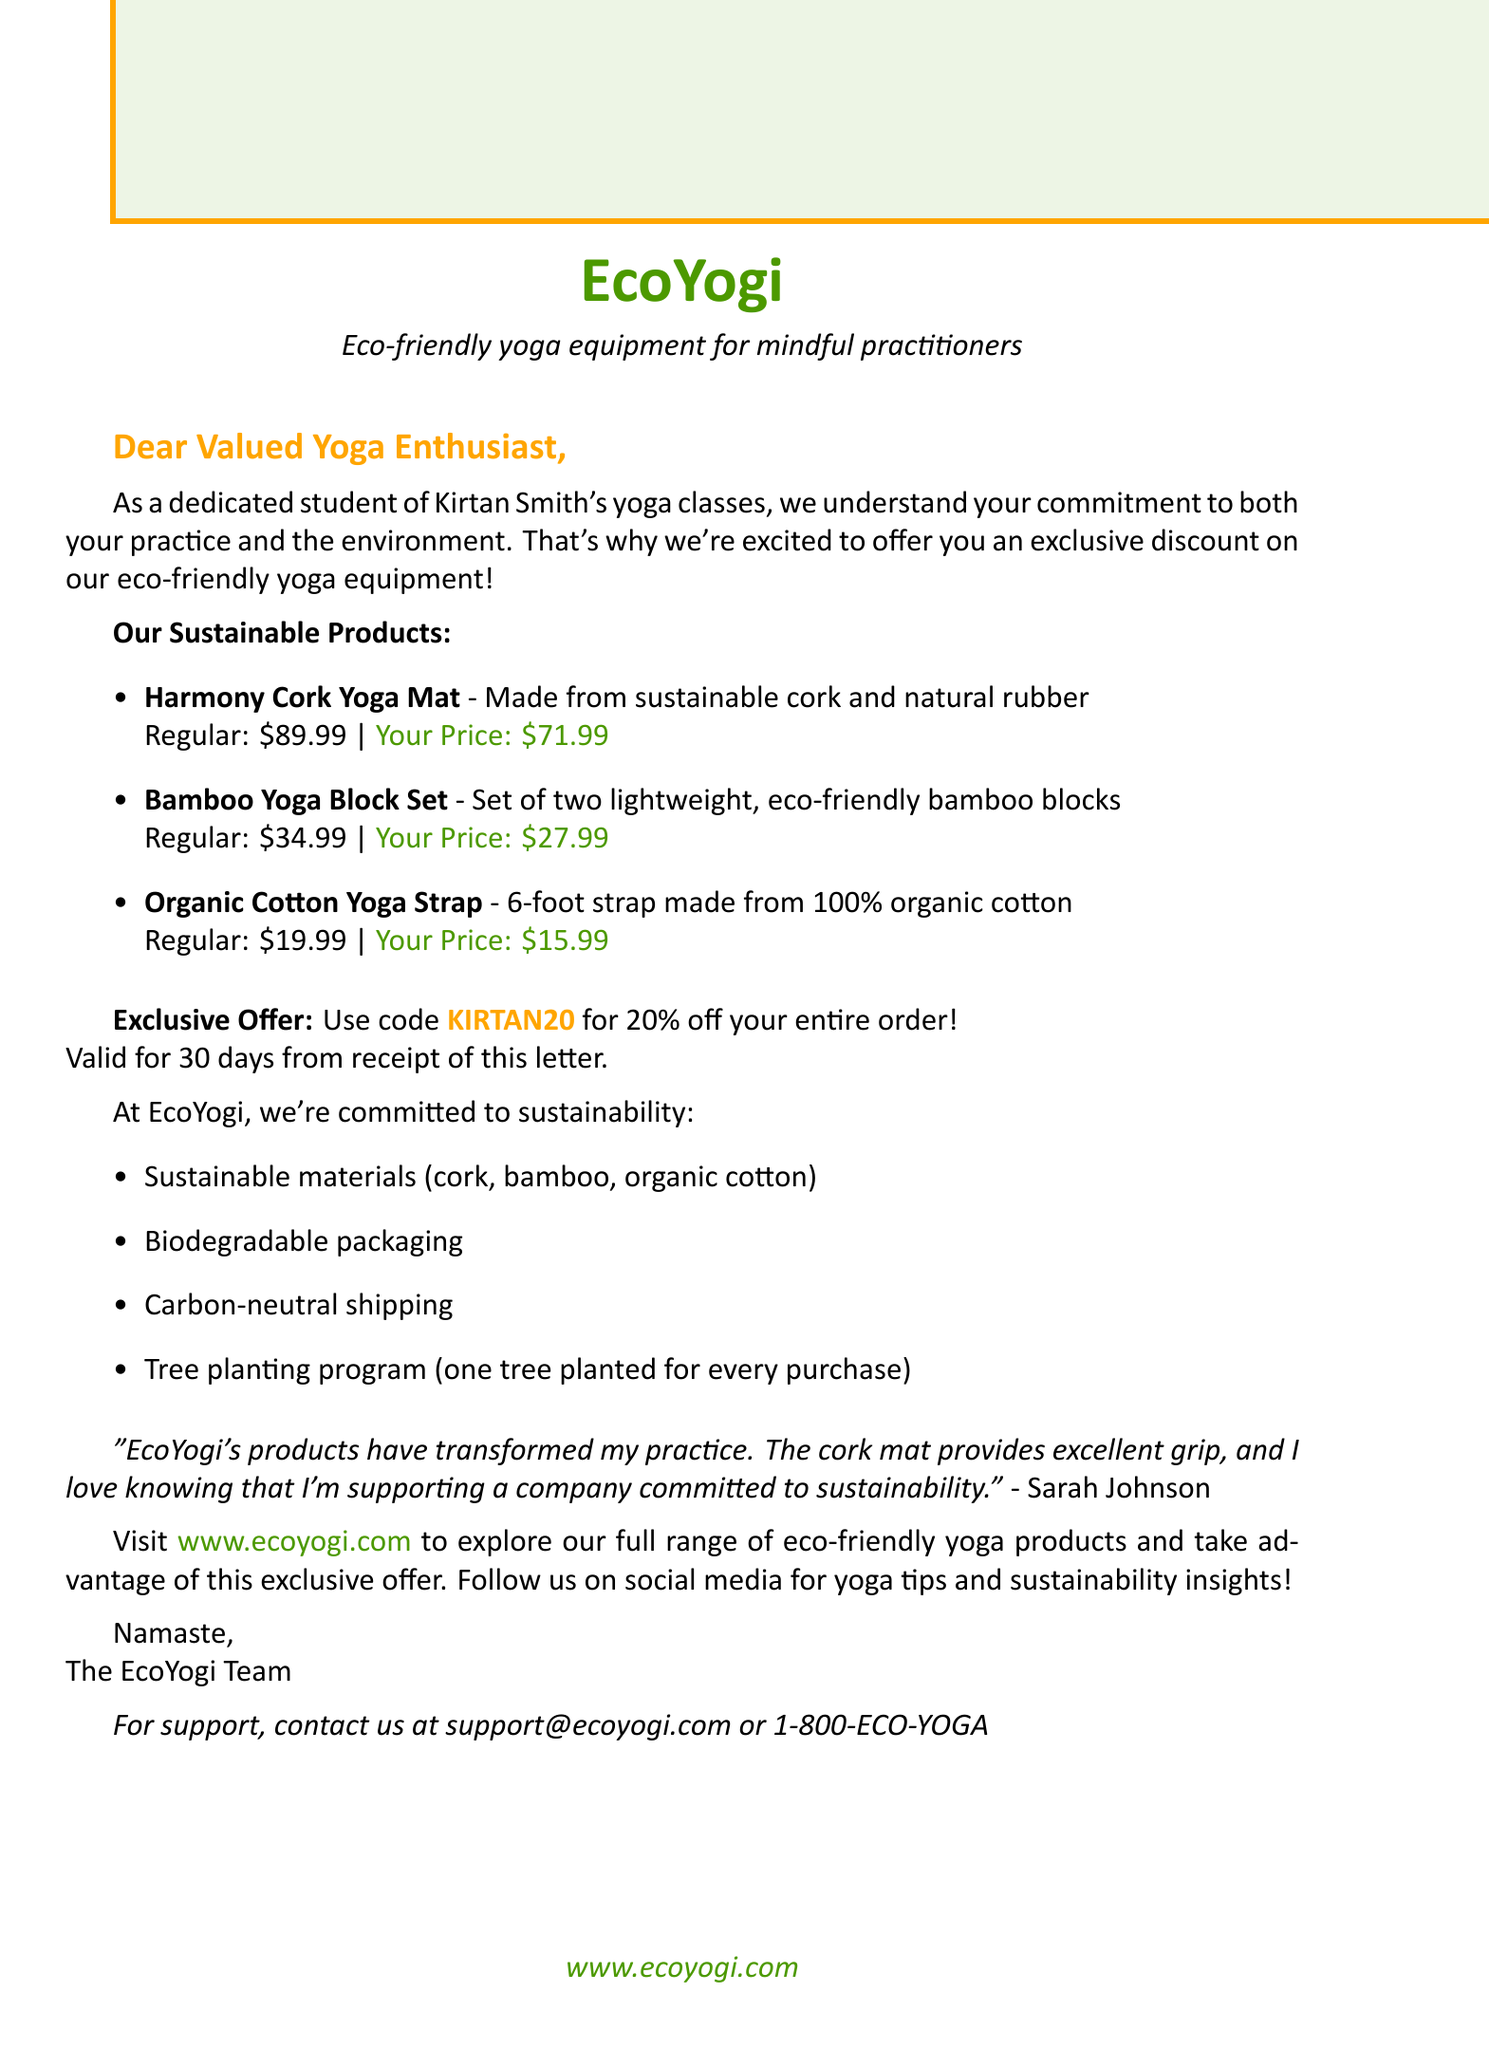What is the name of the yoga equipment company? The company is referred to in the document as EcoYogi.
Answer: EcoYogi What is the discount percentage offered? The document specifies a 20% discount available for customers.
Answer: 20% What is the promotional code for the discount? The letter includes the code to be used for the discount, which is provided within the exclusive offer section.
Answer: KIRTAN20 How long is the discount valid? The document states the discount is valid for 30 days from receipt of the letter.
Answer: 30 days What material is the Harmony Cork Yoga Mat made from? The document explicitly mentions that this yoga mat is made from sustainable cork and natural rubber.
Answer: Sustainable cork and natural rubber What is unique about EcoYogi's shipping? The document outlines that EcoYogi offers carbon-neutral shipping as part of its sustainability commitment.
Answer: Carbon-neutral shipping Who gave the testimonial in the document? The letter includes a testimonial from an individual praising the company's products.
Answer: Sarah Johnson What is included in the Bamboo Yoga Block Set? The product description clearly states that it includes two lightweight, eco-friendly bamboo blocks.
Answer: Two lightweight, eco-friendly bamboo blocks What shared values does EcoYogi and Kirtan Smith's classes promote? The document highlights that both share a commitment to mindfulness and environmental consciousness.
Answer: Mindfulness and environmental consciousness 